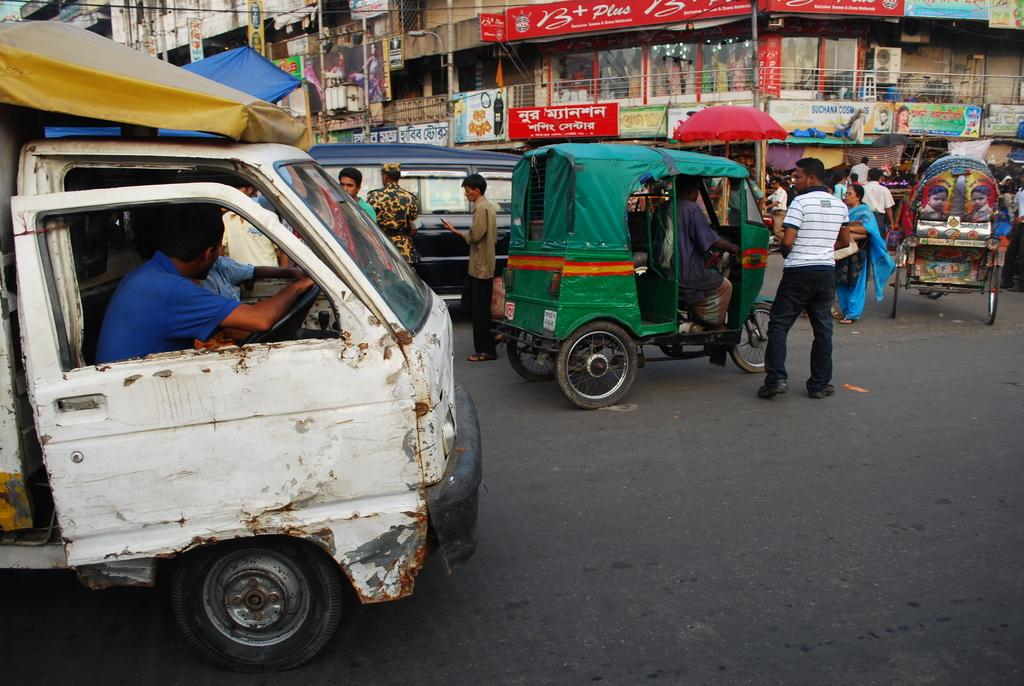<image>
Write a terse but informative summary of the picture. A red banner advertises B Plus on the second level of shops along this busy street. 